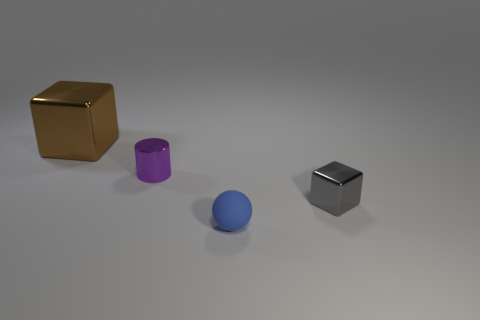Is the number of metallic blocks on the right side of the brown metallic cube greater than the number of cyan metal blocks?
Give a very brief answer. Yes. There is a big brown object that is the same material as the gray thing; what is its shape?
Provide a succinct answer. Cube. What color is the tiny thing in front of the gray block that is in front of the small cylinder?
Offer a terse response. Blue. Do the brown metallic object and the blue rubber thing have the same shape?
Offer a very short reply. No. There is a small thing that is the same shape as the big thing; what is its material?
Offer a terse response. Metal. There is a cube that is in front of the shiny block on the left side of the gray metal object; is there a small purple shiny cylinder to the right of it?
Provide a short and direct response. No. Does the purple thing have the same shape as the small object in front of the gray shiny object?
Keep it short and to the point. No. Are there any other things that are the same color as the ball?
Your answer should be compact. No. Is the color of the small object on the right side of the small blue rubber sphere the same as the shiny thing that is behind the tiny purple metallic cylinder?
Your answer should be very brief. No. Is there a ball?
Make the answer very short. Yes. 